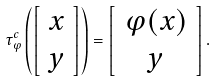<formula> <loc_0><loc_0><loc_500><loc_500>\tau _ { \varphi } ^ { c } \left ( \left [ \begin{array} { l } x \\ y \end{array} \right ] \right ) = \left [ \begin{array} { c } \varphi ( x ) \\ y \end{array} \right ] .</formula> 